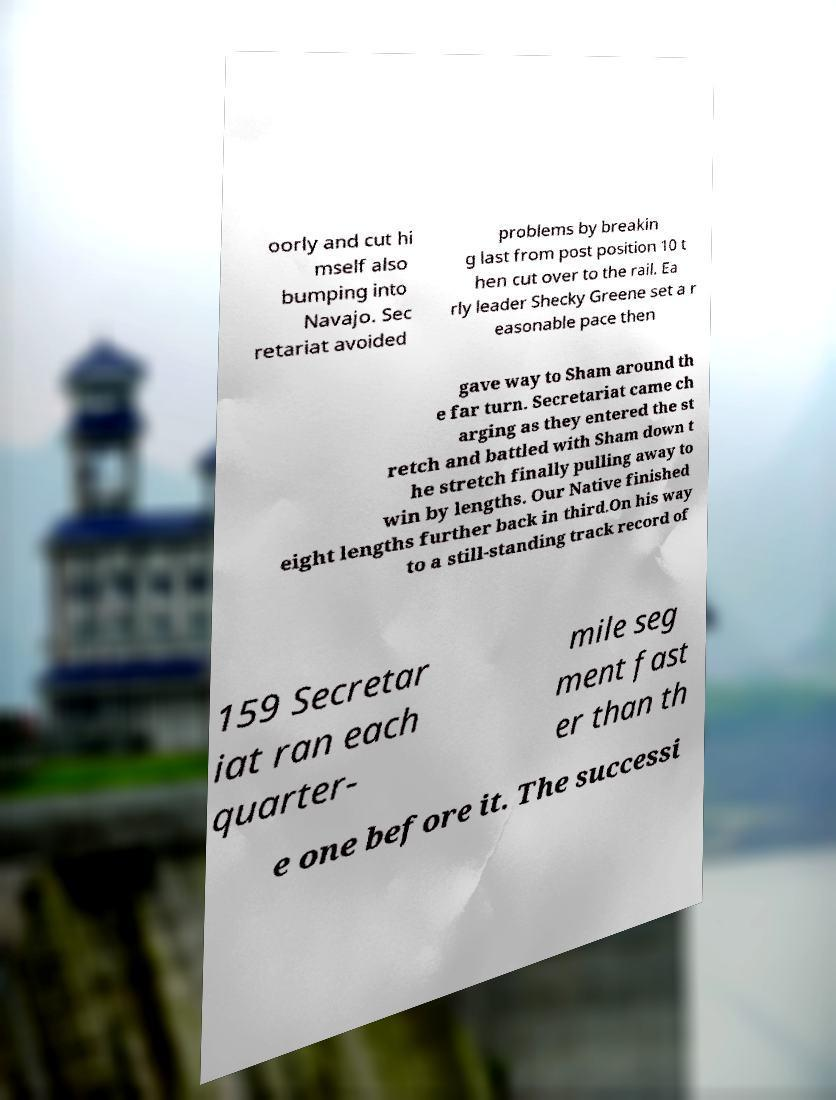I need the written content from this picture converted into text. Can you do that? oorly and cut hi mself also bumping into Navajo. Sec retariat avoided problems by breakin g last from post position 10 t hen cut over to the rail. Ea rly leader Shecky Greene set a r easonable pace then gave way to Sham around th e far turn. Secretariat came ch arging as they entered the st retch and battled with Sham down t he stretch finally pulling away to win by lengths. Our Native finished eight lengths further back in third.On his way to a still-standing track record of 159 Secretar iat ran each quarter- mile seg ment fast er than th e one before it. The successi 